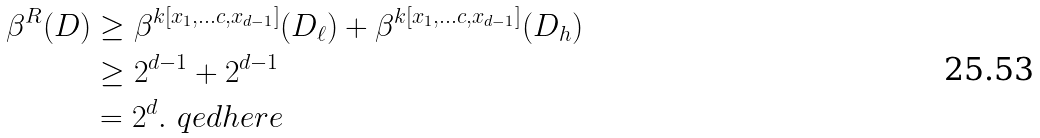Convert formula to latex. <formula><loc_0><loc_0><loc_500><loc_500>\beta ^ { R } ( D ) & \geq \beta ^ { k [ x _ { 1 } , \dots c , x _ { d - 1 } ] } ( D _ { \ell } ) + \beta ^ { k [ x _ { 1 } , \dots c , x _ { d - 1 } ] } ( D _ { h } ) \\ & \geq 2 ^ { d - 1 } + 2 ^ { d - 1 } \\ & = 2 ^ { d } . \ q e d h e r e</formula> 